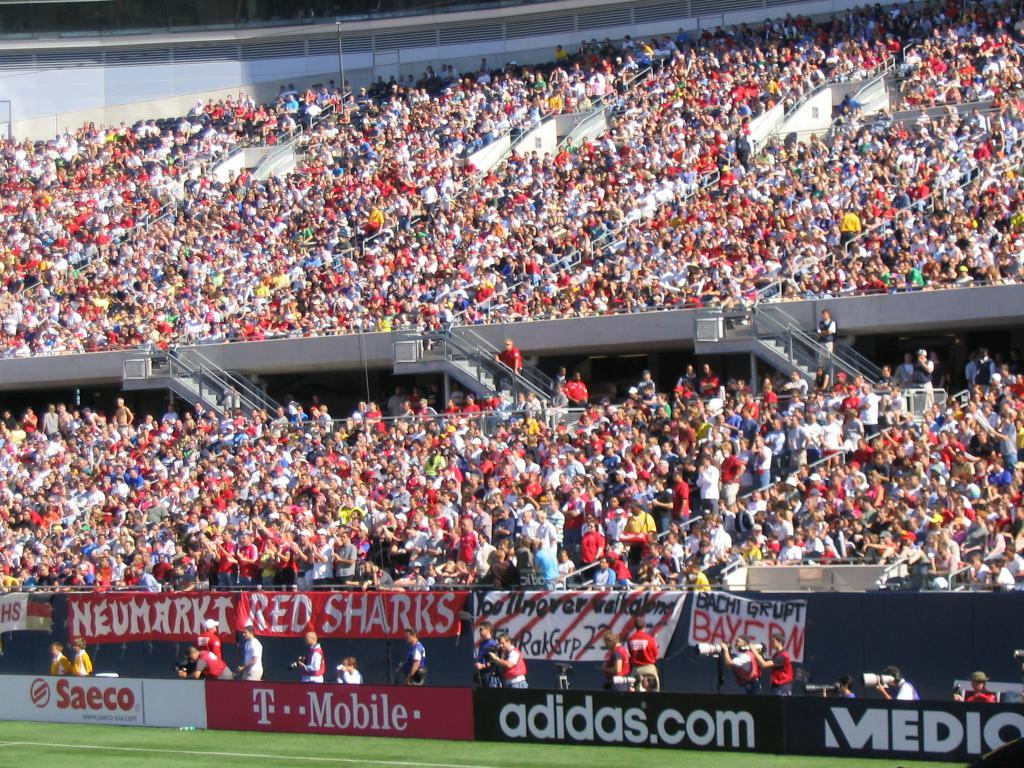What can be seen at the bottom of the image? The ground is visible in the image. What is located in the background of the image? There is an advertisement board, banners, people, staircases, and some objects in the background. How many boys are playing in harmony with the straw in the image? There are no boys or straw present in the image. 